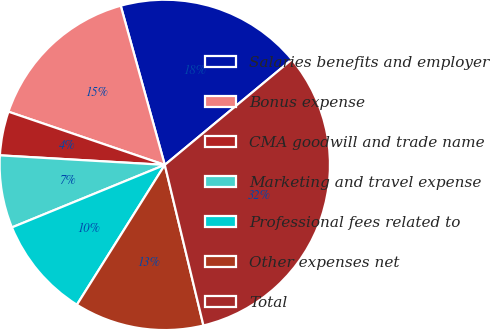<chart> <loc_0><loc_0><loc_500><loc_500><pie_chart><fcel>Salaries benefits and employer<fcel>Bonus expense<fcel>CMA goodwill and trade name<fcel>Marketing and travel expense<fcel>Professional fees related to<fcel>Other expenses net<fcel>Total<nl><fcel>18.28%<fcel>15.48%<fcel>4.3%<fcel>7.1%<fcel>9.89%<fcel>12.69%<fcel>32.26%<nl></chart> 